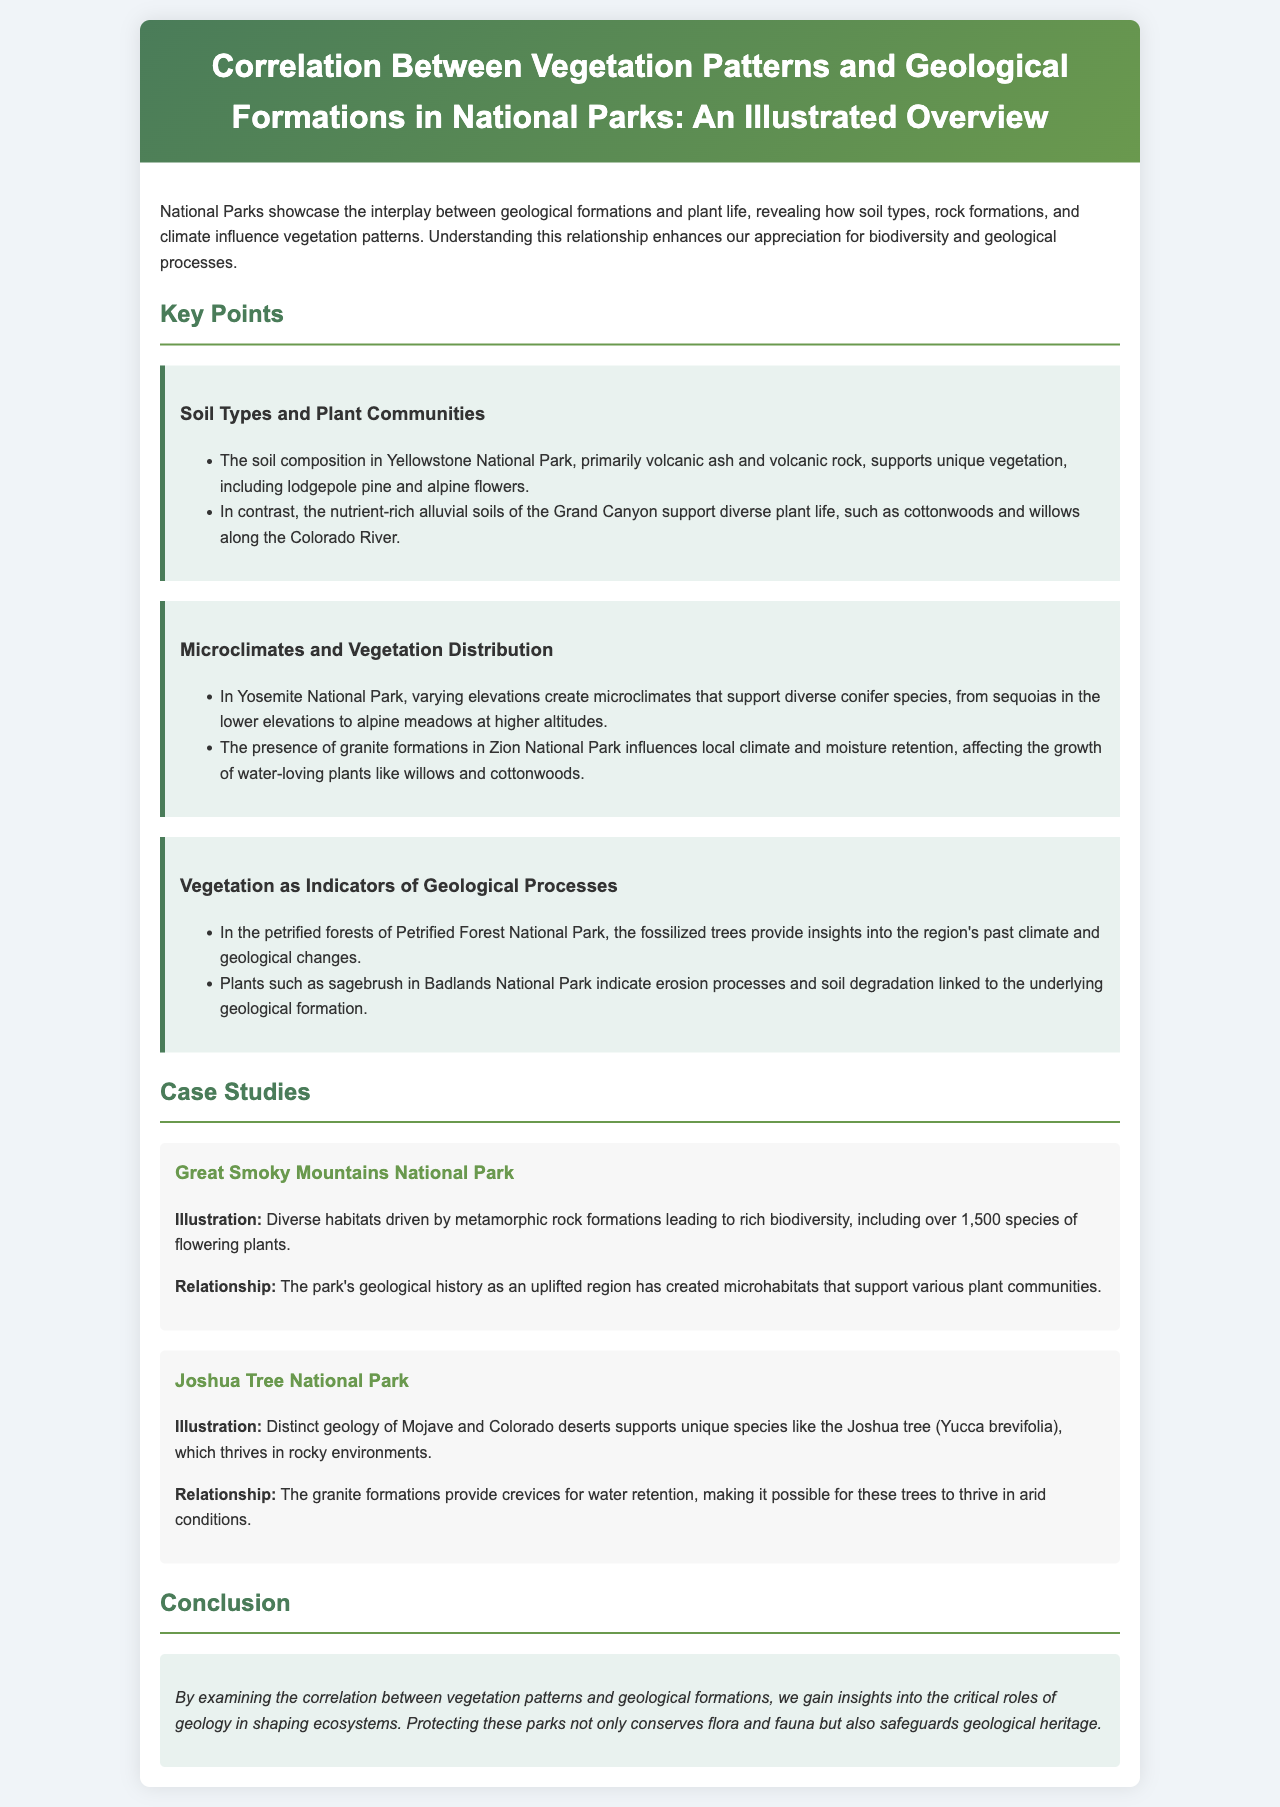What unique vegetation is found in Yellowstone National Park? The document states that lodgepole pine and alpine flowers are unique vegetation in Yellowstone National Park due to its soil composition.
Answer: lodgepole pine and alpine flowers What type of soil is found in the Grand Canyon? The report mentions that the Grand Canyon has nutrient-rich alluvial soils that support diverse plant life.
Answer: nutrient-rich alluvial soils Which park has over 1,500 species of flowering plants? The Great Smoky Mountains National Park is specified to have over 1,500 species of flowering plants due to diverse habitats.
Answer: Great Smoky Mountains National Park What geological formation influences the vegetation in Yosemite National Park? The varying elevations in Yosemite National Park create microclimates that influence the distribution of conifer species.
Answer: varying elevations How do granite formations affect vegetation in Zion National Park? The granite formations in Zion National Park influence local climate and moisture retention, which affects water-loving plants.
Answer: local climate and moisture retention What does sagebrush in Badlands National Park indicate? The presence of sagebrush in Badlands National Park indicates erosion processes and soil degradation linked to geological formations.
Answer: erosion processes and soil degradation What type of desert is Joshua Tree National Park associated with? The document indicates that Joshua Tree National Park features the distinct geology of the Mojave and Colorado deserts.
Answer: Mojave and Colorado deserts Which plant species thrives in the rocky environments of Joshua Tree National Park? The report specifically mentions that the Joshua tree (Yucca brevifolia) thrives in rocky environments within Joshua Tree National Park.
Answer: Joshua tree (Yucca brevifolia) What is the main focus of the report? The report focuses on the correlation between vegetation patterns and geological formations in National Parks.
Answer: correlation between vegetation patterns and geological formations 